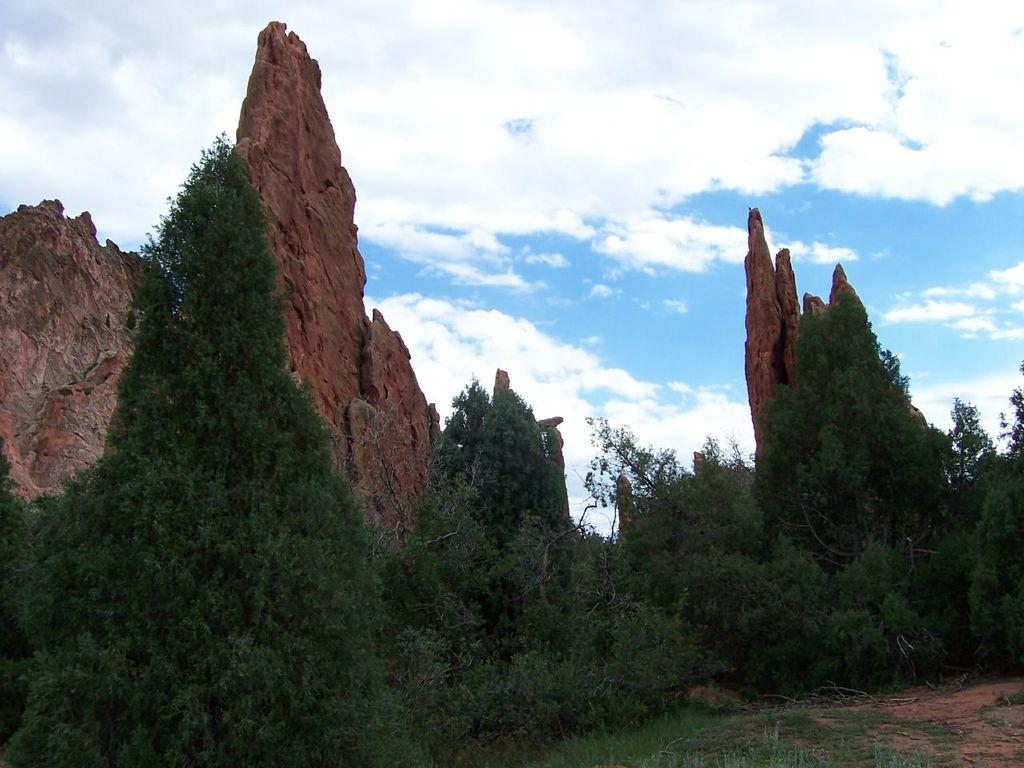What type of geological formation is in the image? There is a rock mountain in the image. What type of vegetation can be seen in the image? There are trees in the image. What is visible at the top of the image? The sky is visible at the top of the image. What can be seen in the sky in the image? Clouds are present in the sky. What is the best way to measure the depth of the recess in the rock mountain? There is no recess mentioned in the image, and the rock mountain is a solid formation. 